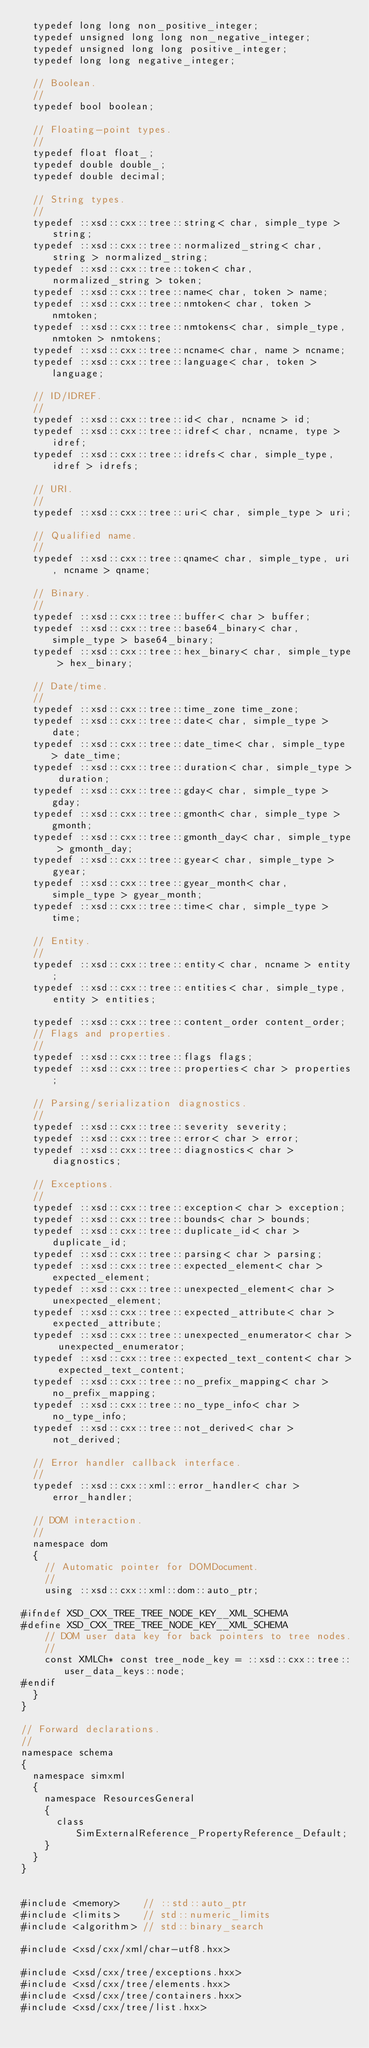Convert code to text. <code><loc_0><loc_0><loc_500><loc_500><_C++_>  typedef long long non_positive_integer;
  typedef unsigned long long non_negative_integer;
  typedef unsigned long long positive_integer;
  typedef long long negative_integer;

  // Boolean.
  //
  typedef bool boolean;

  // Floating-point types.
  //
  typedef float float_;
  typedef double double_;
  typedef double decimal;

  // String types.
  //
  typedef ::xsd::cxx::tree::string< char, simple_type > string;
  typedef ::xsd::cxx::tree::normalized_string< char, string > normalized_string;
  typedef ::xsd::cxx::tree::token< char, normalized_string > token;
  typedef ::xsd::cxx::tree::name< char, token > name;
  typedef ::xsd::cxx::tree::nmtoken< char, token > nmtoken;
  typedef ::xsd::cxx::tree::nmtokens< char, simple_type, nmtoken > nmtokens;
  typedef ::xsd::cxx::tree::ncname< char, name > ncname;
  typedef ::xsd::cxx::tree::language< char, token > language;

  // ID/IDREF.
  //
  typedef ::xsd::cxx::tree::id< char, ncname > id;
  typedef ::xsd::cxx::tree::idref< char, ncname, type > idref;
  typedef ::xsd::cxx::tree::idrefs< char, simple_type, idref > idrefs;

  // URI.
  //
  typedef ::xsd::cxx::tree::uri< char, simple_type > uri;

  // Qualified name.
  //
  typedef ::xsd::cxx::tree::qname< char, simple_type, uri, ncname > qname;

  // Binary.
  //
  typedef ::xsd::cxx::tree::buffer< char > buffer;
  typedef ::xsd::cxx::tree::base64_binary< char, simple_type > base64_binary;
  typedef ::xsd::cxx::tree::hex_binary< char, simple_type > hex_binary;

  // Date/time.
  //
  typedef ::xsd::cxx::tree::time_zone time_zone;
  typedef ::xsd::cxx::tree::date< char, simple_type > date;
  typedef ::xsd::cxx::tree::date_time< char, simple_type > date_time;
  typedef ::xsd::cxx::tree::duration< char, simple_type > duration;
  typedef ::xsd::cxx::tree::gday< char, simple_type > gday;
  typedef ::xsd::cxx::tree::gmonth< char, simple_type > gmonth;
  typedef ::xsd::cxx::tree::gmonth_day< char, simple_type > gmonth_day;
  typedef ::xsd::cxx::tree::gyear< char, simple_type > gyear;
  typedef ::xsd::cxx::tree::gyear_month< char, simple_type > gyear_month;
  typedef ::xsd::cxx::tree::time< char, simple_type > time;

  // Entity.
  //
  typedef ::xsd::cxx::tree::entity< char, ncname > entity;
  typedef ::xsd::cxx::tree::entities< char, simple_type, entity > entities;

  typedef ::xsd::cxx::tree::content_order content_order;
  // Flags and properties.
  //
  typedef ::xsd::cxx::tree::flags flags;
  typedef ::xsd::cxx::tree::properties< char > properties;

  // Parsing/serialization diagnostics.
  //
  typedef ::xsd::cxx::tree::severity severity;
  typedef ::xsd::cxx::tree::error< char > error;
  typedef ::xsd::cxx::tree::diagnostics< char > diagnostics;

  // Exceptions.
  //
  typedef ::xsd::cxx::tree::exception< char > exception;
  typedef ::xsd::cxx::tree::bounds< char > bounds;
  typedef ::xsd::cxx::tree::duplicate_id< char > duplicate_id;
  typedef ::xsd::cxx::tree::parsing< char > parsing;
  typedef ::xsd::cxx::tree::expected_element< char > expected_element;
  typedef ::xsd::cxx::tree::unexpected_element< char > unexpected_element;
  typedef ::xsd::cxx::tree::expected_attribute< char > expected_attribute;
  typedef ::xsd::cxx::tree::unexpected_enumerator< char > unexpected_enumerator;
  typedef ::xsd::cxx::tree::expected_text_content< char > expected_text_content;
  typedef ::xsd::cxx::tree::no_prefix_mapping< char > no_prefix_mapping;
  typedef ::xsd::cxx::tree::no_type_info< char > no_type_info;
  typedef ::xsd::cxx::tree::not_derived< char > not_derived;

  // Error handler callback interface.
  //
  typedef ::xsd::cxx::xml::error_handler< char > error_handler;

  // DOM interaction.
  //
  namespace dom
  {
    // Automatic pointer for DOMDocument.
    //
    using ::xsd::cxx::xml::dom::auto_ptr;

#ifndef XSD_CXX_TREE_TREE_NODE_KEY__XML_SCHEMA
#define XSD_CXX_TREE_TREE_NODE_KEY__XML_SCHEMA
    // DOM user data key for back pointers to tree nodes.
    //
    const XMLCh* const tree_node_key = ::xsd::cxx::tree::user_data_keys::node;
#endif
  }
}

// Forward declarations.
//
namespace schema
{
  namespace simxml
  {
    namespace ResourcesGeneral
    {
      class SimExternalReference_PropertyReference_Default;
    }
  }
}


#include <memory>    // ::std::auto_ptr
#include <limits>    // std::numeric_limits
#include <algorithm> // std::binary_search

#include <xsd/cxx/xml/char-utf8.hxx>

#include <xsd/cxx/tree/exceptions.hxx>
#include <xsd/cxx/tree/elements.hxx>
#include <xsd/cxx/tree/containers.hxx>
#include <xsd/cxx/tree/list.hxx>
</code> 